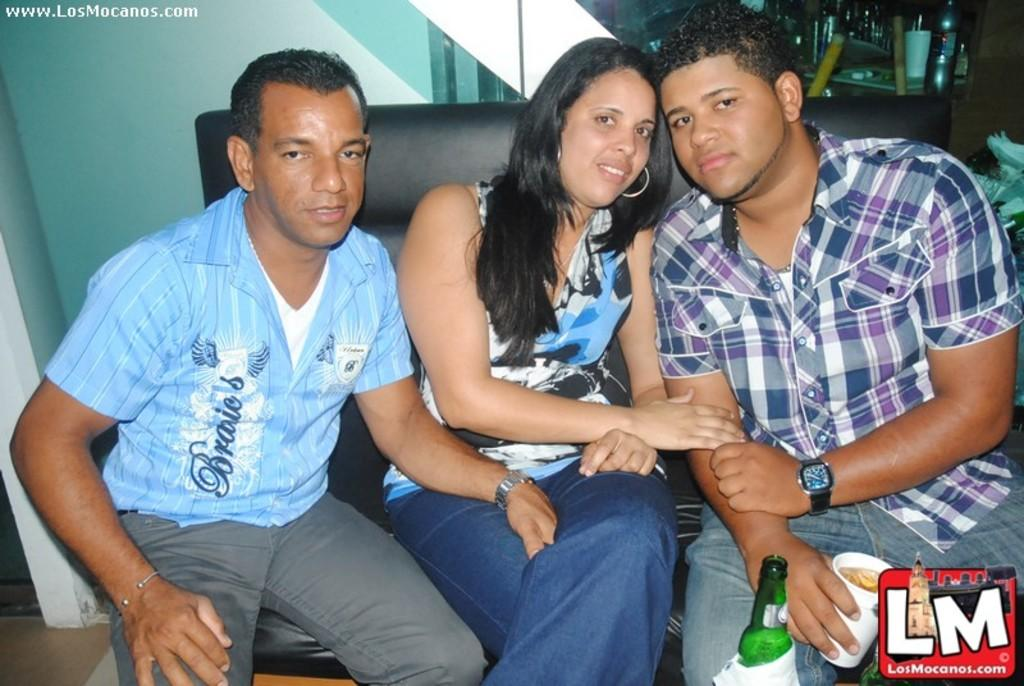<image>
Offer a succinct explanation of the picture presented. Three people posing for a photo with the letters LM below them. 